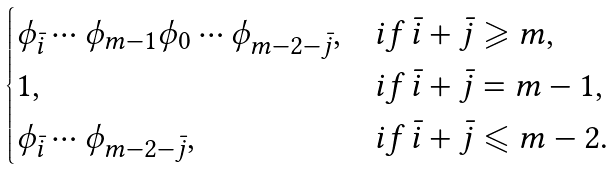<formula> <loc_0><loc_0><loc_500><loc_500>\begin{cases} \phi _ { \bar { i } } \cdots \phi _ { m - 1 } \phi _ { 0 } \cdots \phi _ { m - 2 - \bar { j } } , & i f \, \bar { i } + \bar { j } \geqslant m , \\ 1 , & i f \, \bar { i } + \bar { j } = m - 1 , \\ \phi _ { \bar { i } } \cdots \phi _ { m - 2 - \bar { j } } , & i f \, \bar { i } + \bar { j } \leqslant m - 2 . \end{cases}</formula> 